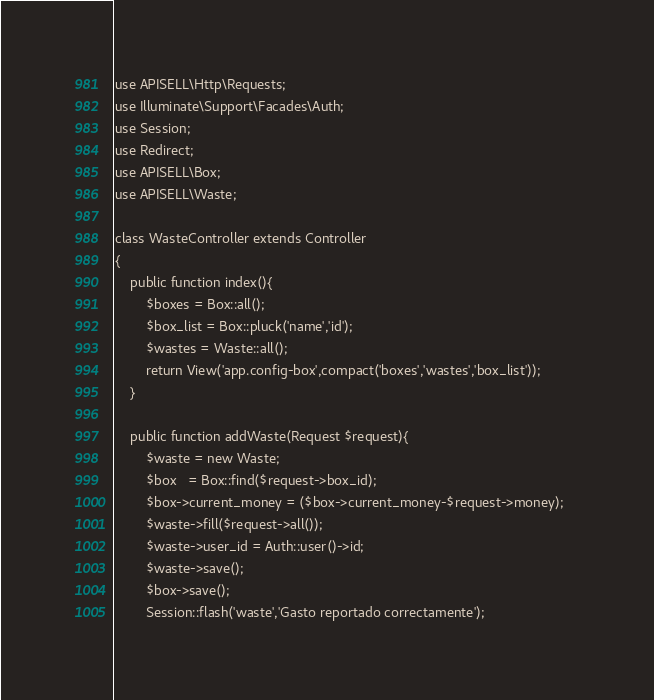<code> <loc_0><loc_0><loc_500><loc_500><_PHP_>
use APISELL\Http\Requests;
use Illuminate\Support\Facades\Auth;
use Session;
use Redirect;
use APISELL\Box;
use APISELL\Waste;

class WasteController extends Controller
{
    public function index(){
    	$boxes = Box::all();
    	$box_list = Box::pluck('name','id');
    	$wastes = Waste::all();
    	return View('app.config-box',compact('boxes','wastes','box_list'));
    }

    public function addWaste(Request $request){
    	$waste = new Waste;
    	$box   = Box::find($request->box_id);    
    	$box->current_money = ($box->current_money-$request->money);    
    	$waste->fill($request->all());
    	$waste->user_id = Auth::user()->id;
    	$waste->save();
    	$box->save();
    	Session::flash('waste','Gasto reportado correctamente');</code> 